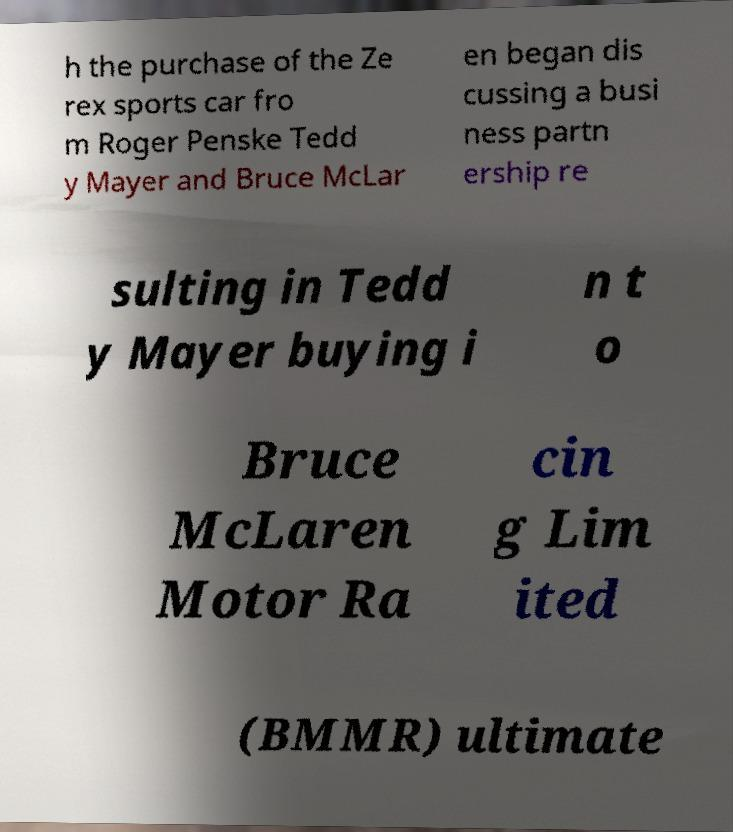I need the written content from this picture converted into text. Can you do that? h the purchase of the Ze rex sports car fro m Roger Penske Tedd y Mayer and Bruce McLar en began dis cussing a busi ness partn ership re sulting in Tedd y Mayer buying i n t o Bruce McLaren Motor Ra cin g Lim ited (BMMR) ultimate 